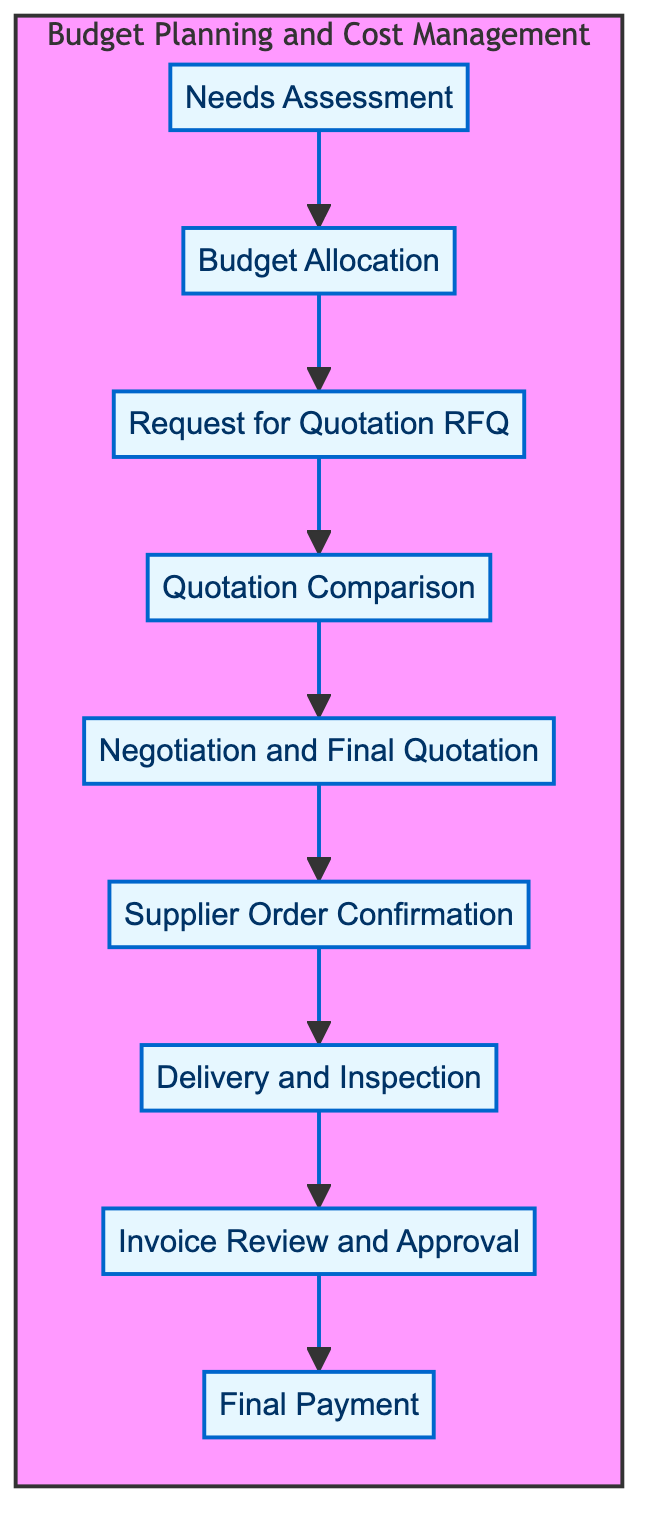What is the first step in the process? The first step in the flow diagram is 'Needs Assessment,' which is positioned at the bottom of the diagram. This is the initial stage where business requirements are assessed to determine the type and quantity of plastic insulation needed.
Answer: Needs Assessment How many steps are there in total? The diagram consists of a total of eight steps, which are all connected in a linear flow from bottom to top, starting from 'Needs Assessment' and ending with 'Final Payment.'
Answer: Eight Which step comes immediately after 'Quotation Comparison'? After 'Quotation Comparison,' the next step is 'Negotiation and Final Quotation.' This step is located directly above in the flowing sequence.
Answer: Negotiation and Final Quotation What is the last step before making the final payment? The final step before making the last payment is 'Invoice Review and Approval.' This step involves evaluating the received invoice for correctness prior to the final payment process.
Answer: Invoice Review and Approval Identify the step that follows the 'Supplier Order Confirmation'. Following 'Supplier Order Confirmation' in the flow is 'Delivery and Inspection.' This means that once the order is confirmed, the delivery and subsequent inspection occur next in the sequence.
Answer: Delivery and Inspection What are the two steps before 'Final Payment'? The two steps before 'Final Payment' are 'Invoice Review and Approval' and 'Delivery and Inspection.' When working through the diagram from the end to the beginning, these are the two preceding stages to the final payment process.
Answer: Invoice Review and Approval, Delivery and Inspection How does 'Budget Allocation' relate to 'Request for Quotation'? 'Budget Allocation' is the step that comes directly before 'Request for Quotation' in the flow chart. After budget allocation based on initial estimates, the next action is sending out requests for quotes from suppliers.
Answer: Directly before Which step involves confirming the accuracy of an invoice? The step that involves confirming the accuracy of an invoice is 'Invoice Review and Approval.' This is where the received invoice is evaluated before the final payment process.
Answer: Invoice Review and Approval What is the final step in the budget planning process? The final step in the budget planning process depicted in the flow diagram is 'Final Payment.' This step represents the culmination of the entire budgeting and cost management process following all previous steps.
Answer: Final Payment 